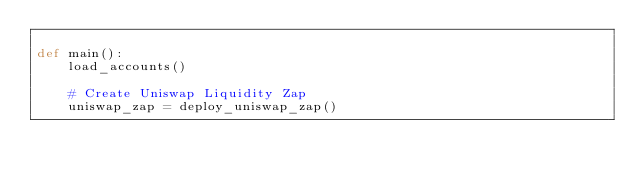Convert code to text. <code><loc_0><loc_0><loc_500><loc_500><_Python_>
def main():
    load_accounts()

    # Create Uniswap Liquidity Zap
    uniswap_zap = deploy_uniswap_zap()
    
</code> 